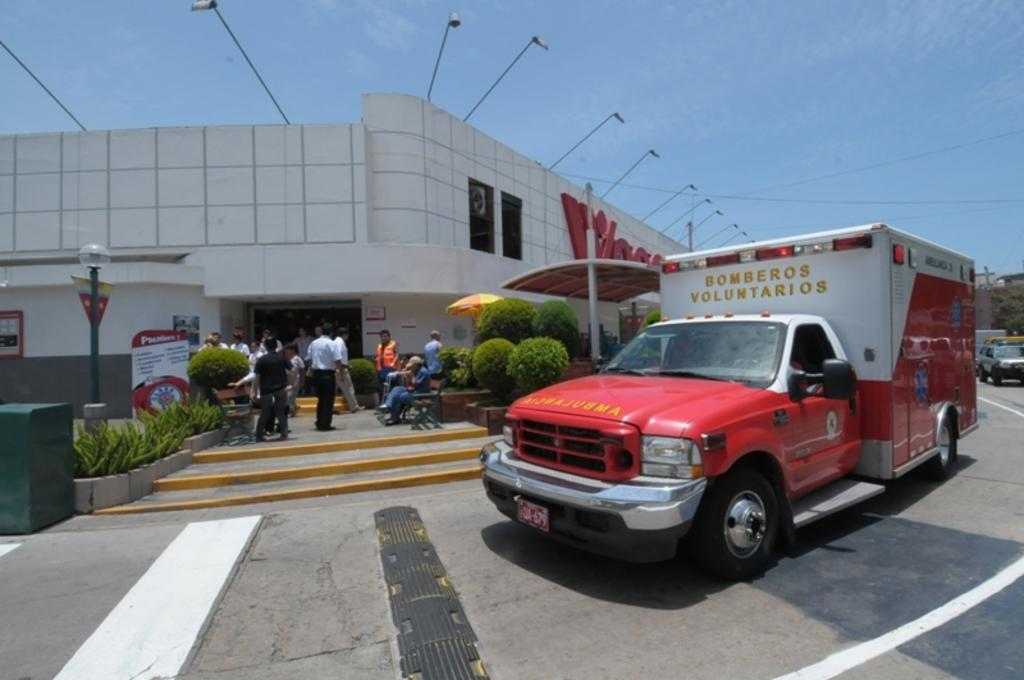How many people are the people in the image? There are people in the image. What structures can be seen in the image? There are buildings in the image. What objects are present in the image that might be used for support or signage? There are poles and boards in the image. What can be used for illumination in the image? There are lights in the image. What architectural feature is present in the image that allows for vertical movement? There are stairs in the image. What type of transportation is visible in the image? There are vehicles in the image. What type of surface can be seen in the image that is used for traveling? There is a road in the image. What type of natural elements are present in the image? There are plants in the image. What is visible at the top of the image? The sky is visible in the image. What type of button can be seen on the people's clothing in the image? There is no button visible on the people's clothing in the image. What is the wealth status of the people in the image? There is no information about the wealth status of the people in the image. 